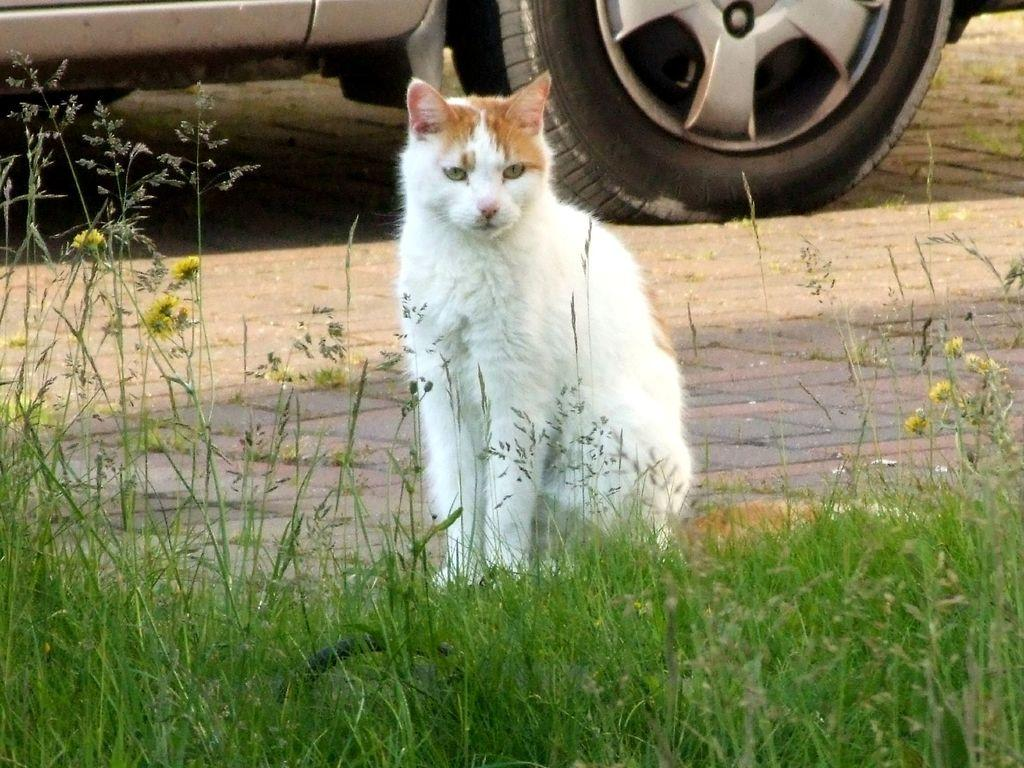What is the main subject in the center of the image? There is a cat in the center of the image. What type of vegetation is at the bottom of the image? There is grass at the bottom of the image. What can be seen in the background of the image? There is a car visible in the background of the image. Where is the car located in relation to the road? The car is on a road. How many goldfish are swimming in the grass in the image? There are no goldfish present in the image; it features a cat and grass. What type of prison can be seen in the background of the image? There is no prison visible in the background of the image; it features a car on a road. 